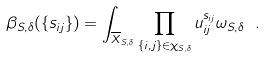<formula> <loc_0><loc_0><loc_500><loc_500>\beta _ { S , \delta } ( \{ s _ { i j } \} ) = \int _ { \overline { X } _ { S , \delta } } \prod _ { \{ i , j \} \in \chi _ { S , \delta } } u _ { i j } ^ { s _ { i j } } \omega _ { S , \delta } \ .</formula> 